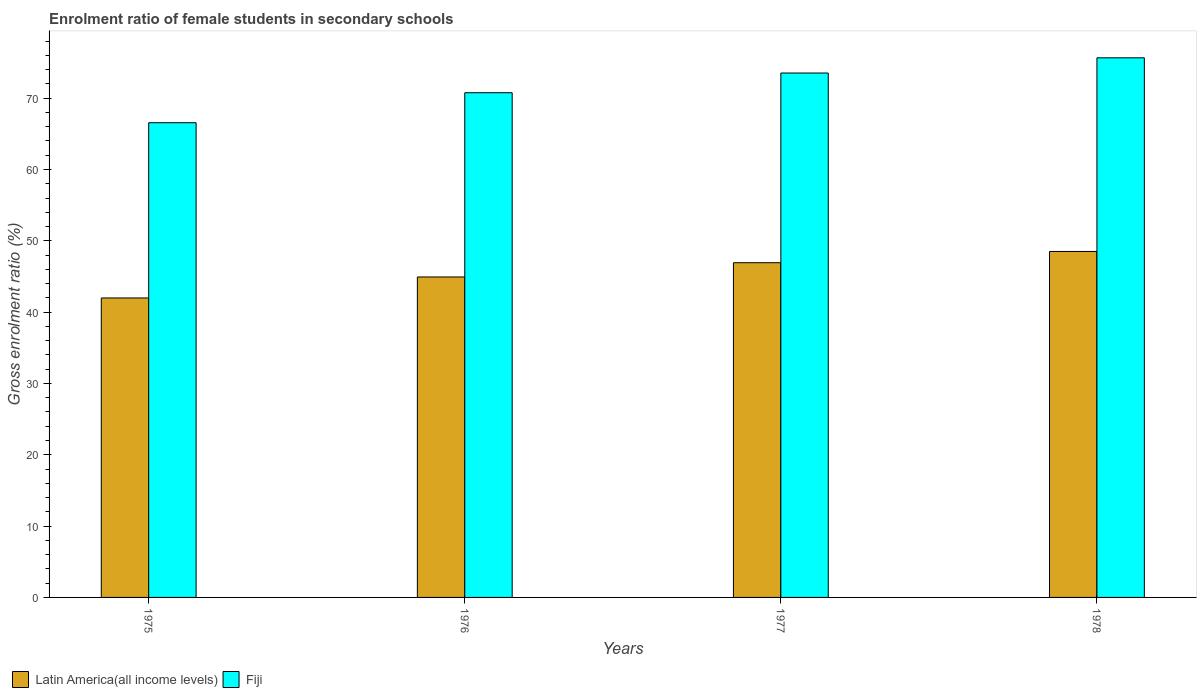How many different coloured bars are there?
Provide a short and direct response. 2. How many bars are there on the 2nd tick from the left?
Provide a succinct answer. 2. How many bars are there on the 3rd tick from the right?
Make the answer very short. 2. What is the label of the 4th group of bars from the left?
Your answer should be very brief. 1978. What is the enrolment ratio of female students in secondary schools in Fiji in 1975?
Your answer should be very brief. 66.56. Across all years, what is the maximum enrolment ratio of female students in secondary schools in Fiji?
Offer a terse response. 75.66. Across all years, what is the minimum enrolment ratio of female students in secondary schools in Fiji?
Make the answer very short. 66.56. In which year was the enrolment ratio of female students in secondary schools in Latin America(all income levels) maximum?
Give a very brief answer. 1978. In which year was the enrolment ratio of female students in secondary schools in Fiji minimum?
Offer a very short reply. 1975. What is the total enrolment ratio of female students in secondary schools in Fiji in the graph?
Keep it short and to the point. 286.51. What is the difference between the enrolment ratio of female students in secondary schools in Latin America(all income levels) in 1975 and that in 1978?
Your response must be concise. -6.52. What is the difference between the enrolment ratio of female students in secondary schools in Fiji in 1977 and the enrolment ratio of female students in secondary schools in Latin America(all income levels) in 1976?
Give a very brief answer. 28.59. What is the average enrolment ratio of female students in secondary schools in Fiji per year?
Offer a terse response. 71.63. In the year 1975, what is the difference between the enrolment ratio of female students in secondary schools in Latin America(all income levels) and enrolment ratio of female students in secondary schools in Fiji?
Your answer should be compact. -24.57. In how many years, is the enrolment ratio of female students in secondary schools in Fiji greater than 26 %?
Your answer should be very brief. 4. What is the ratio of the enrolment ratio of female students in secondary schools in Latin America(all income levels) in 1975 to that in 1976?
Offer a very short reply. 0.93. Is the enrolment ratio of female students in secondary schools in Fiji in 1975 less than that in 1978?
Provide a short and direct response. Yes. Is the difference between the enrolment ratio of female students in secondary schools in Latin America(all income levels) in 1976 and 1978 greater than the difference between the enrolment ratio of female students in secondary schools in Fiji in 1976 and 1978?
Give a very brief answer. Yes. What is the difference between the highest and the second highest enrolment ratio of female students in secondary schools in Fiji?
Your answer should be very brief. 2.13. What is the difference between the highest and the lowest enrolment ratio of female students in secondary schools in Fiji?
Your answer should be compact. 9.1. Is the sum of the enrolment ratio of female students in secondary schools in Fiji in 1975 and 1977 greater than the maximum enrolment ratio of female students in secondary schools in Latin America(all income levels) across all years?
Give a very brief answer. Yes. What does the 1st bar from the left in 1978 represents?
Offer a very short reply. Latin America(all income levels). What does the 2nd bar from the right in 1977 represents?
Your response must be concise. Latin America(all income levels). How many years are there in the graph?
Keep it short and to the point. 4. What is the difference between two consecutive major ticks on the Y-axis?
Your response must be concise. 10. Are the values on the major ticks of Y-axis written in scientific E-notation?
Offer a terse response. No. How many legend labels are there?
Give a very brief answer. 2. How are the legend labels stacked?
Provide a succinct answer. Horizontal. What is the title of the graph?
Offer a terse response. Enrolment ratio of female students in secondary schools. Does "Tuvalu" appear as one of the legend labels in the graph?
Offer a terse response. No. What is the label or title of the X-axis?
Offer a terse response. Years. What is the Gross enrolment ratio (%) of Latin America(all income levels) in 1975?
Provide a short and direct response. 41.99. What is the Gross enrolment ratio (%) in Fiji in 1975?
Make the answer very short. 66.56. What is the Gross enrolment ratio (%) in Latin America(all income levels) in 1976?
Provide a short and direct response. 44.93. What is the Gross enrolment ratio (%) in Fiji in 1976?
Make the answer very short. 70.77. What is the Gross enrolment ratio (%) in Latin America(all income levels) in 1977?
Offer a very short reply. 46.93. What is the Gross enrolment ratio (%) in Fiji in 1977?
Ensure brevity in your answer.  73.53. What is the Gross enrolment ratio (%) in Latin America(all income levels) in 1978?
Keep it short and to the point. 48.51. What is the Gross enrolment ratio (%) of Fiji in 1978?
Keep it short and to the point. 75.66. Across all years, what is the maximum Gross enrolment ratio (%) in Latin America(all income levels)?
Offer a very short reply. 48.51. Across all years, what is the maximum Gross enrolment ratio (%) of Fiji?
Provide a succinct answer. 75.66. Across all years, what is the minimum Gross enrolment ratio (%) in Latin America(all income levels)?
Ensure brevity in your answer.  41.99. Across all years, what is the minimum Gross enrolment ratio (%) of Fiji?
Keep it short and to the point. 66.56. What is the total Gross enrolment ratio (%) in Latin America(all income levels) in the graph?
Offer a terse response. 182.36. What is the total Gross enrolment ratio (%) of Fiji in the graph?
Offer a very short reply. 286.51. What is the difference between the Gross enrolment ratio (%) in Latin America(all income levels) in 1975 and that in 1976?
Your answer should be compact. -2.94. What is the difference between the Gross enrolment ratio (%) of Fiji in 1975 and that in 1976?
Your answer should be very brief. -4.21. What is the difference between the Gross enrolment ratio (%) of Latin America(all income levels) in 1975 and that in 1977?
Make the answer very short. -4.94. What is the difference between the Gross enrolment ratio (%) in Fiji in 1975 and that in 1977?
Offer a very short reply. -6.97. What is the difference between the Gross enrolment ratio (%) in Latin America(all income levels) in 1975 and that in 1978?
Provide a succinct answer. -6.52. What is the difference between the Gross enrolment ratio (%) of Fiji in 1975 and that in 1978?
Keep it short and to the point. -9.1. What is the difference between the Gross enrolment ratio (%) in Latin America(all income levels) in 1976 and that in 1977?
Provide a succinct answer. -2. What is the difference between the Gross enrolment ratio (%) of Fiji in 1976 and that in 1977?
Keep it short and to the point. -2.76. What is the difference between the Gross enrolment ratio (%) of Latin America(all income levels) in 1976 and that in 1978?
Offer a terse response. -3.58. What is the difference between the Gross enrolment ratio (%) of Fiji in 1976 and that in 1978?
Ensure brevity in your answer.  -4.9. What is the difference between the Gross enrolment ratio (%) in Latin America(all income levels) in 1977 and that in 1978?
Keep it short and to the point. -1.58. What is the difference between the Gross enrolment ratio (%) of Fiji in 1977 and that in 1978?
Offer a terse response. -2.13. What is the difference between the Gross enrolment ratio (%) of Latin America(all income levels) in 1975 and the Gross enrolment ratio (%) of Fiji in 1976?
Offer a terse response. -28.78. What is the difference between the Gross enrolment ratio (%) in Latin America(all income levels) in 1975 and the Gross enrolment ratio (%) in Fiji in 1977?
Your answer should be compact. -31.54. What is the difference between the Gross enrolment ratio (%) of Latin America(all income levels) in 1975 and the Gross enrolment ratio (%) of Fiji in 1978?
Your response must be concise. -33.67. What is the difference between the Gross enrolment ratio (%) of Latin America(all income levels) in 1976 and the Gross enrolment ratio (%) of Fiji in 1977?
Your answer should be compact. -28.59. What is the difference between the Gross enrolment ratio (%) of Latin America(all income levels) in 1976 and the Gross enrolment ratio (%) of Fiji in 1978?
Your response must be concise. -30.73. What is the difference between the Gross enrolment ratio (%) in Latin America(all income levels) in 1977 and the Gross enrolment ratio (%) in Fiji in 1978?
Keep it short and to the point. -28.73. What is the average Gross enrolment ratio (%) in Latin America(all income levels) per year?
Make the answer very short. 45.59. What is the average Gross enrolment ratio (%) in Fiji per year?
Provide a short and direct response. 71.63. In the year 1975, what is the difference between the Gross enrolment ratio (%) of Latin America(all income levels) and Gross enrolment ratio (%) of Fiji?
Your answer should be compact. -24.57. In the year 1976, what is the difference between the Gross enrolment ratio (%) in Latin America(all income levels) and Gross enrolment ratio (%) in Fiji?
Your answer should be compact. -25.83. In the year 1977, what is the difference between the Gross enrolment ratio (%) in Latin America(all income levels) and Gross enrolment ratio (%) in Fiji?
Keep it short and to the point. -26.59. In the year 1978, what is the difference between the Gross enrolment ratio (%) of Latin America(all income levels) and Gross enrolment ratio (%) of Fiji?
Give a very brief answer. -27.15. What is the ratio of the Gross enrolment ratio (%) in Latin America(all income levels) in 1975 to that in 1976?
Make the answer very short. 0.93. What is the ratio of the Gross enrolment ratio (%) of Fiji in 1975 to that in 1976?
Ensure brevity in your answer.  0.94. What is the ratio of the Gross enrolment ratio (%) of Latin America(all income levels) in 1975 to that in 1977?
Your answer should be compact. 0.89. What is the ratio of the Gross enrolment ratio (%) of Fiji in 1975 to that in 1977?
Provide a short and direct response. 0.91. What is the ratio of the Gross enrolment ratio (%) in Latin America(all income levels) in 1975 to that in 1978?
Provide a short and direct response. 0.87. What is the ratio of the Gross enrolment ratio (%) in Fiji in 1975 to that in 1978?
Give a very brief answer. 0.88. What is the ratio of the Gross enrolment ratio (%) in Latin America(all income levels) in 1976 to that in 1977?
Keep it short and to the point. 0.96. What is the ratio of the Gross enrolment ratio (%) of Fiji in 1976 to that in 1977?
Your answer should be very brief. 0.96. What is the ratio of the Gross enrolment ratio (%) of Latin America(all income levels) in 1976 to that in 1978?
Make the answer very short. 0.93. What is the ratio of the Gross enrolment ratio (%) of Fiji in 1976 to that in 1978?
Provide a short and direct response. 0.94. What is the ratio of the Gross enrolment ratio (%) in Latin America(all income levels) in 1977 to that in 1978?
Provide a succinct answer. 0.97. What is the ratio of the Gross enrolment ratio (%) of Fiji in 1977 to that in 1978?
Offer a terse response. 0.97. What is the difference between the highest and the second highest Gross enrolment ratio (%) in Latin America(all income levels)?
Keep it short and to the point. 1.58. What is the difference between the highest and the second highest Gross enrolment ratio (%) of Fiji?
Provide a succinct answer. 2.13. What is the difference between the highest and the lowest Gross enrolment ratio (%) in Latin America(all income levels)?
Offer a terse response. 6.52. What is the difference between the highest and the lowest Gross enrolment ratio (%) in Fiji?
Your response must be concise. 9.1. 